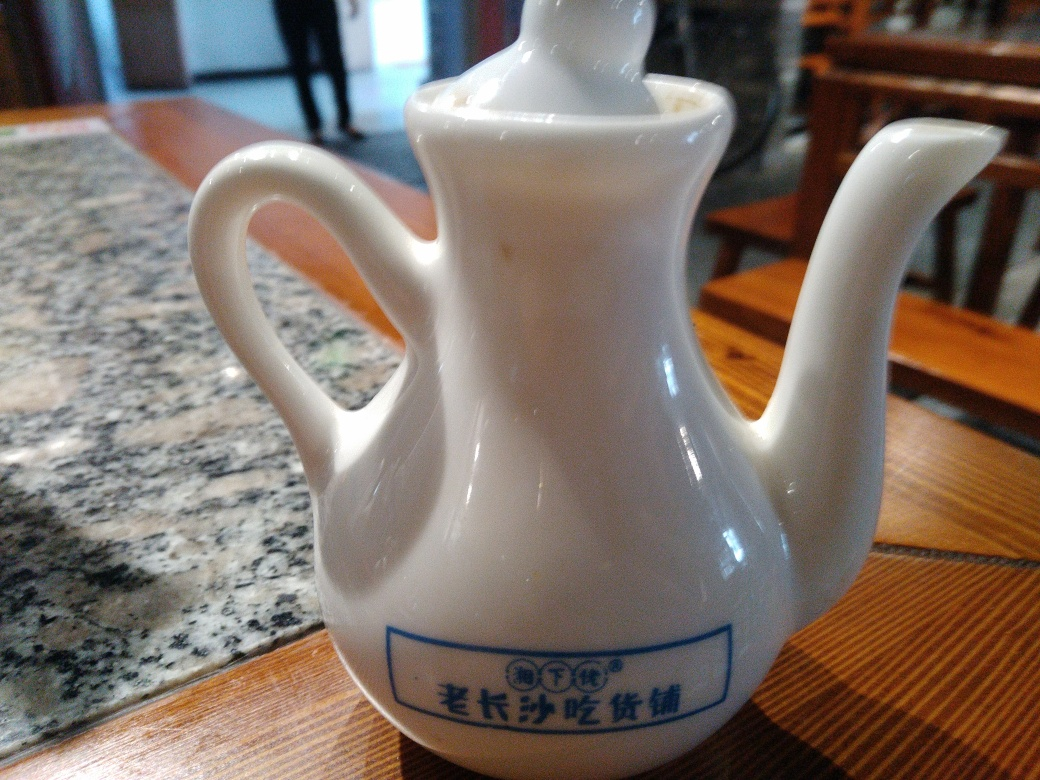Is there any text or markings on the teapot that indicate its origin or brand? Yes, there are Chinese characters along with some symbols on the side of the teapot. While I can't provide a translation, such markings often include the name of the manufacturer, the region of production, or the brand. These details can be indicative of the teapot's origin, suggesting it may be from a region with a strong tea culture or a specific maker known for quality craft. 